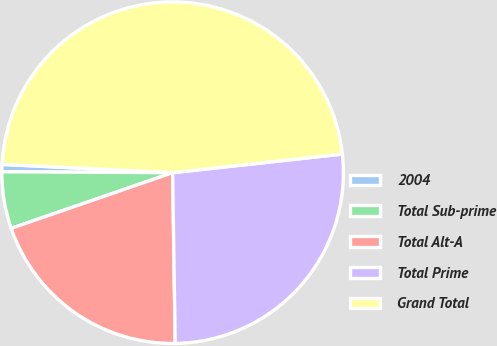<chart> <loc_0><loc_0><loc_500><loc_500><pie_chart><fcel>2004<fcel>Total Sub-prime<fcel>Total Alt-A<fcel>Total Prime<fcel>Grand Total<nl><fcel>0.69%<fcel>5.37%<fcel>19.96%<fcel>26.5%<fcel>47.49%<nl></chart> 